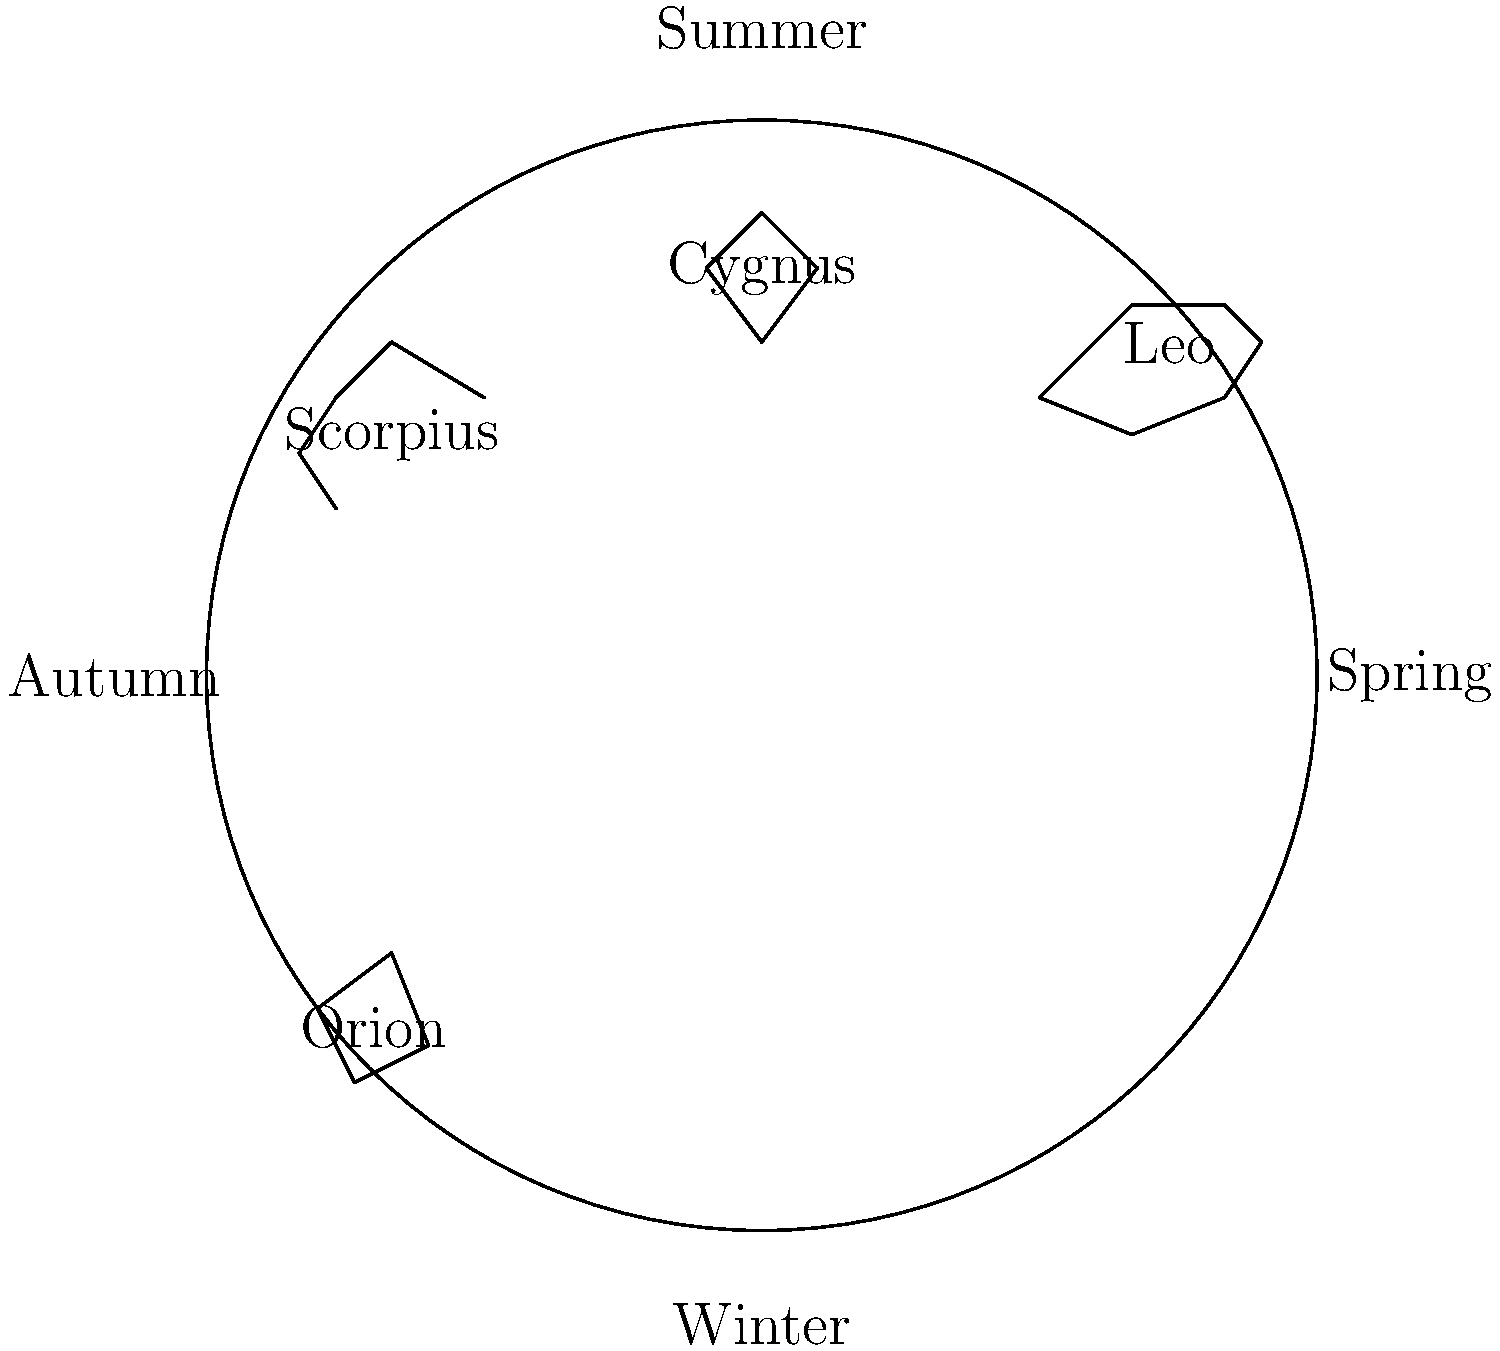Which constellation, visible during summer nights in the Northern Hemisphere, was historically associated with the myth of Zeus transforming himself into a swan, and how did ancient civilizations use it for navigation? 1. The constellation visible during summer nights in the Northern Hemisphere that is associated with Zeus transforming into a swan is Cygnus, the Swan.

2. Historical significance:
   a. In Greek mythology, Cygnus represents Zeus who transformed into a swan to seduce Leda, the queen of Sparta.
   b. The myth reflects the importance of celestial observations in ancient storytelling and cultural practices.

3. Navigation use:
   a. Ancient civilizations, particularly seafarers, used Cygnus for navigation due to its distinctive cross-like shape, also known as the Northern Cross.
   b. The bright star Deneb, located at the tail of the swan, forms part of the Summer Triangle asterism along with Vega and Altair.
   c. Sailors used the Summer Triangle to determine their position and direction during summer nights.

4. Astronomical importance:
   a. Cygnus lies along the Milky Way, making it a rich area for observing deep-sky objects.
   b. The constellation contains several notable stars and deep-sky objects, including the binary star Albireo and the North America Nebula.

5. Cultural significance:
   a. Many cultures recognized this constellation, often associating it with birds.
   b. Native American tribes saw it as the Birdfoot constellation, while Chinese astronomy included it in the Heavenly Emperor's northern palace.

In summary, Cygnus, visible in summer, has significant historical, mythological, and practical importance in navigation and cultural practices across various civilizations.
Answer: Cygnus; used as the Northern Cross for celestial navigation 